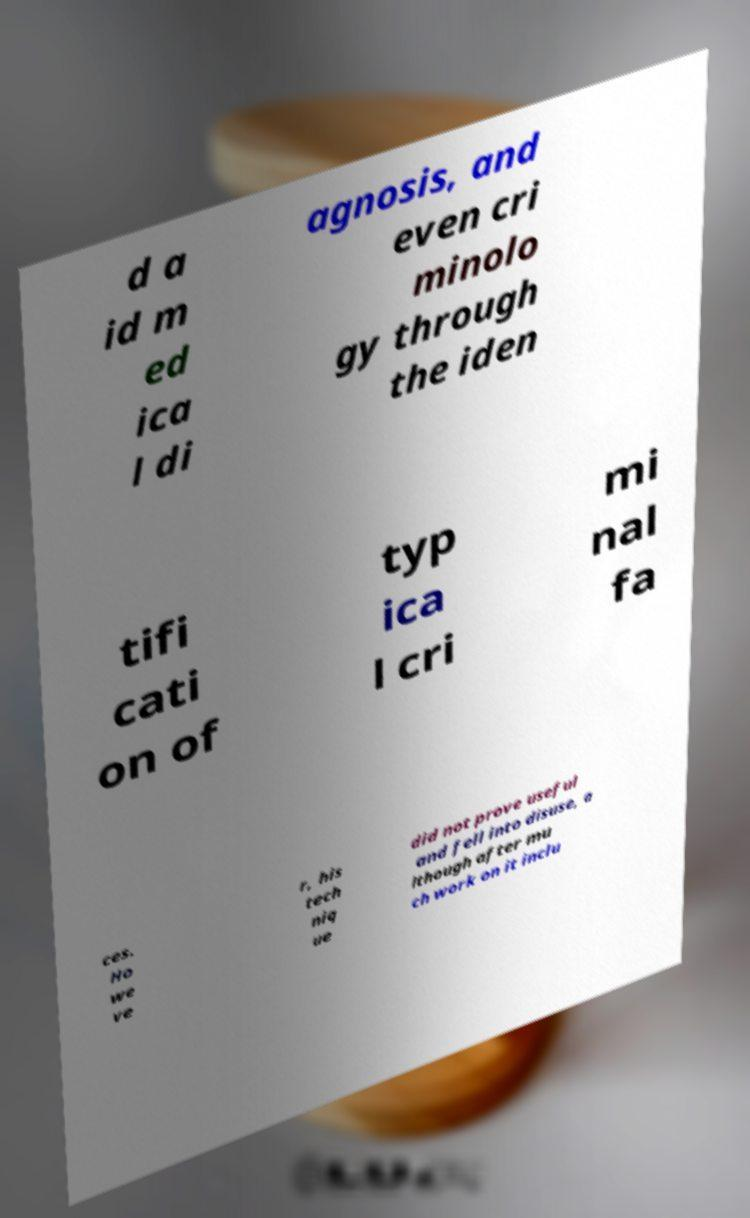Please read and relay the text visible in this image. What does it say? d a id m ed ica l di agnosis, and even cri minolo gy through the iden tifi cati on of typ ica l cri mi nal fa ces. Ho we ve r, his tech niq ue did not prove useful and fell into disuse, a lthough after mu ch work on it inclu 